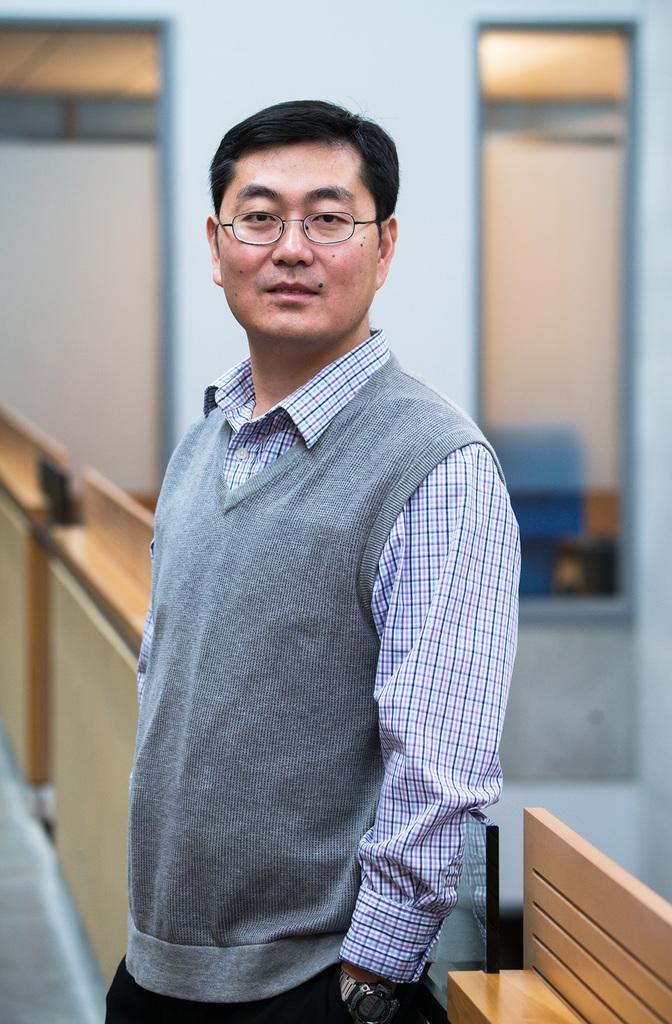Who is present in the image? There is a man in the image. What is the man doing in the image? The man is standing on the floor. What type of tiger can be seen in the image? There is no tiger present in the image; it only features a man standing on the floor. 